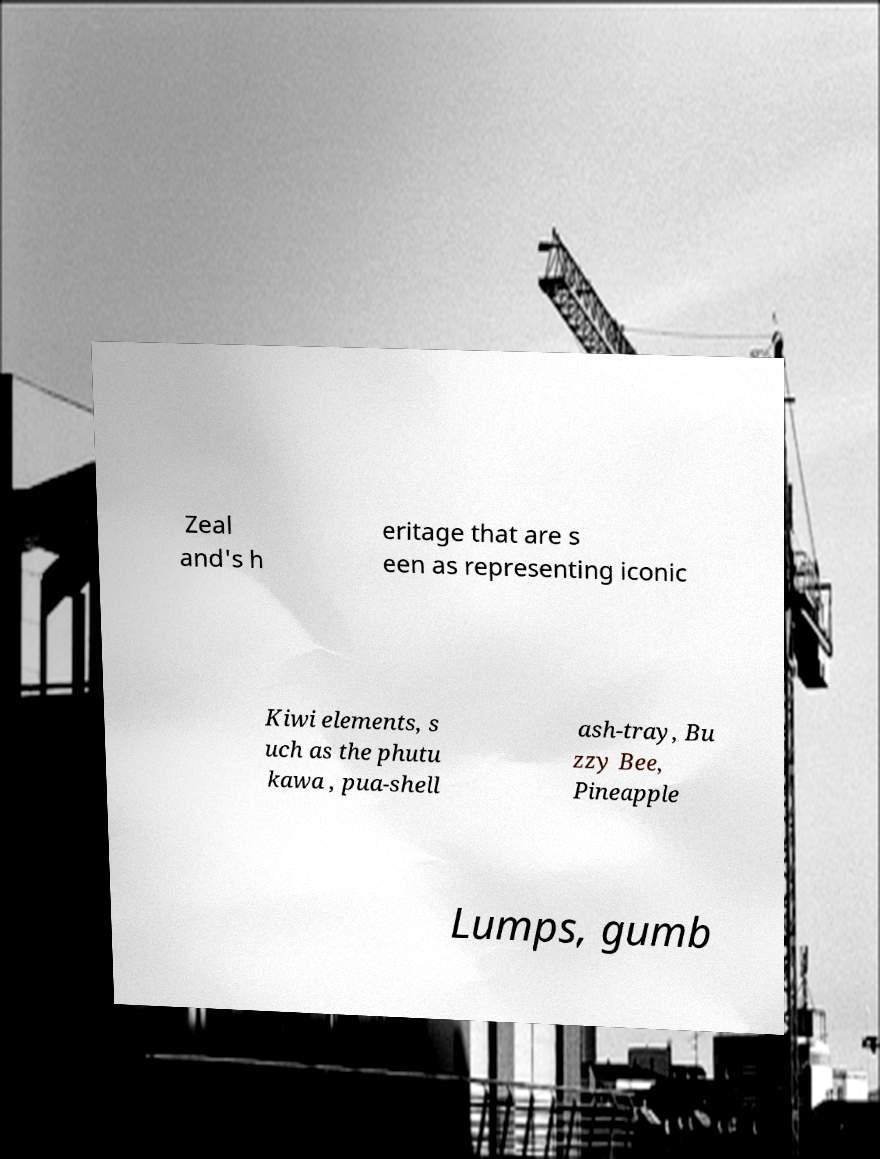For documentation purposes, I need the text within this image transcribed. Could you provide that? Zeal and's h eritage that are s een as representing iconic Kiwi elements, s uch as the phutu kawa , pua-shell ash-tray, Bu zzy Bee, Pineapple Lumps, gumb 